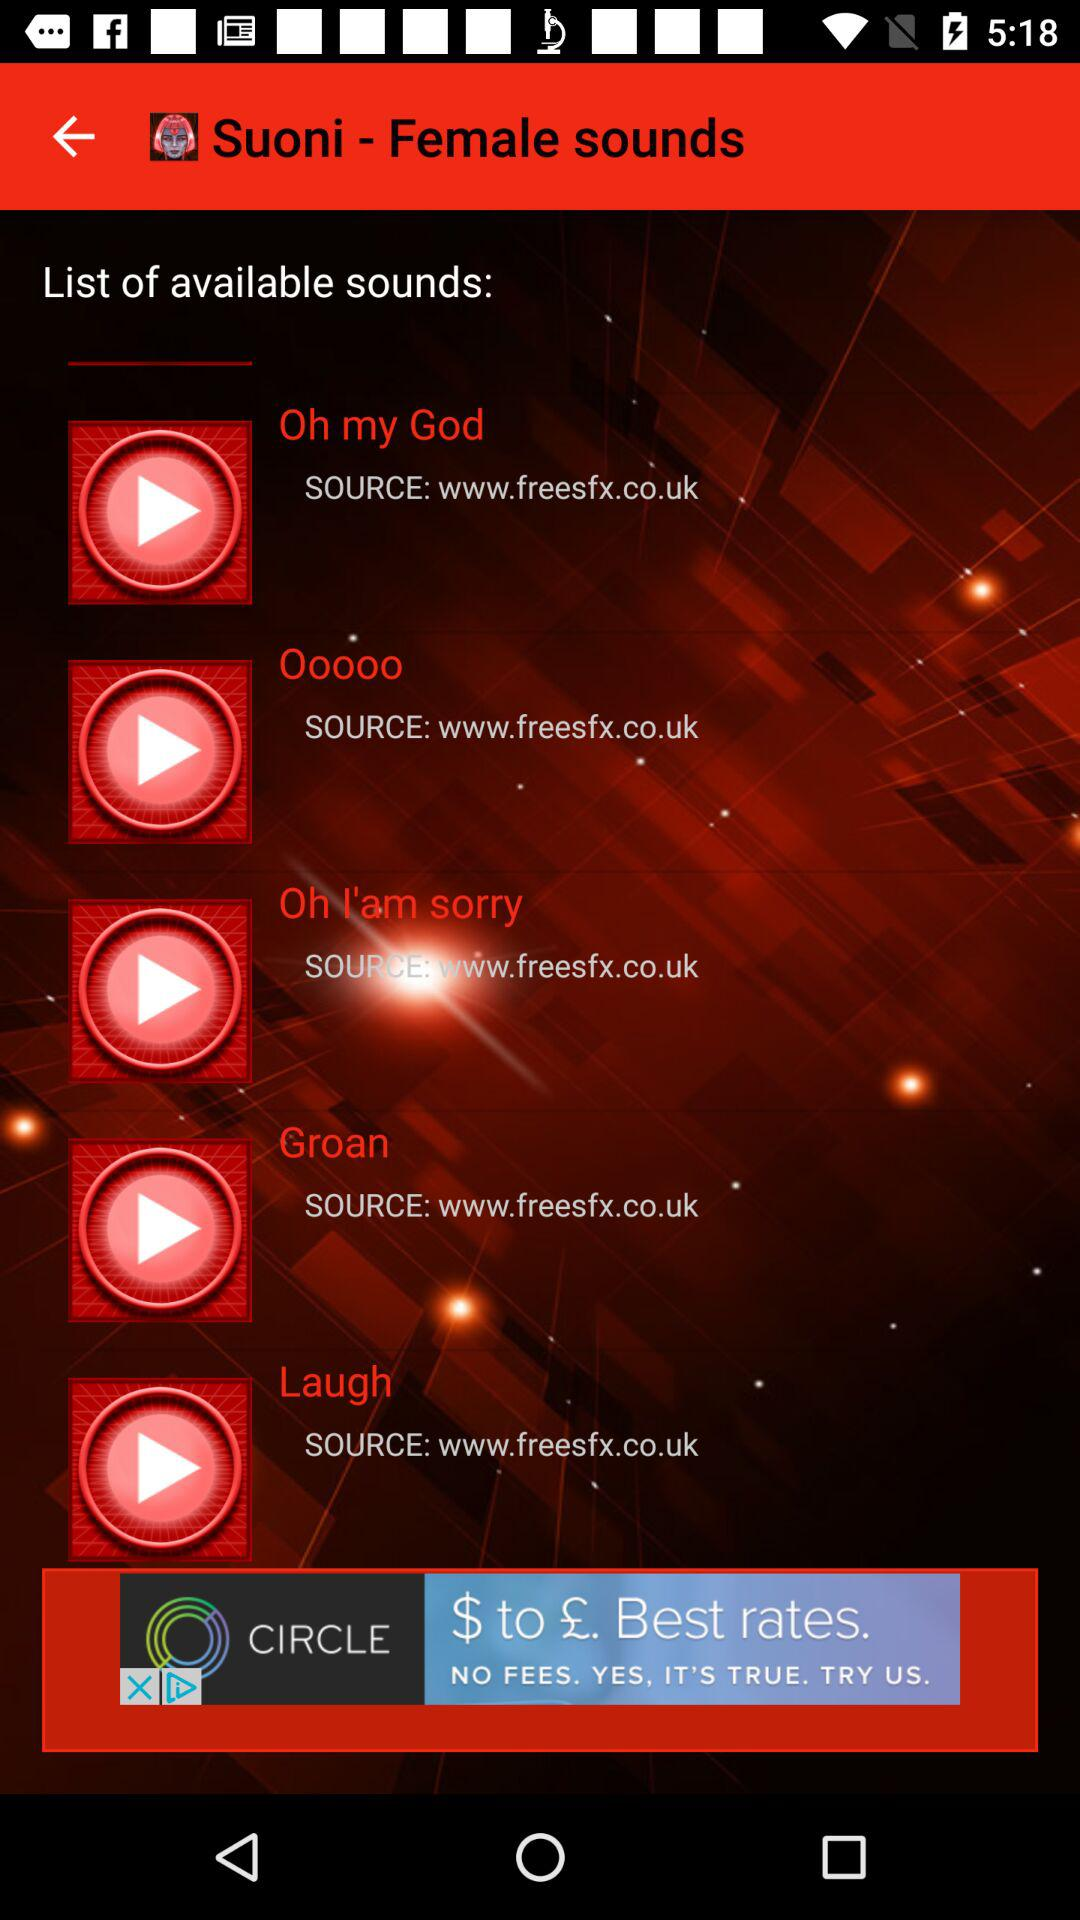What is the application name? The application name is "Suoni - Female sounds". 